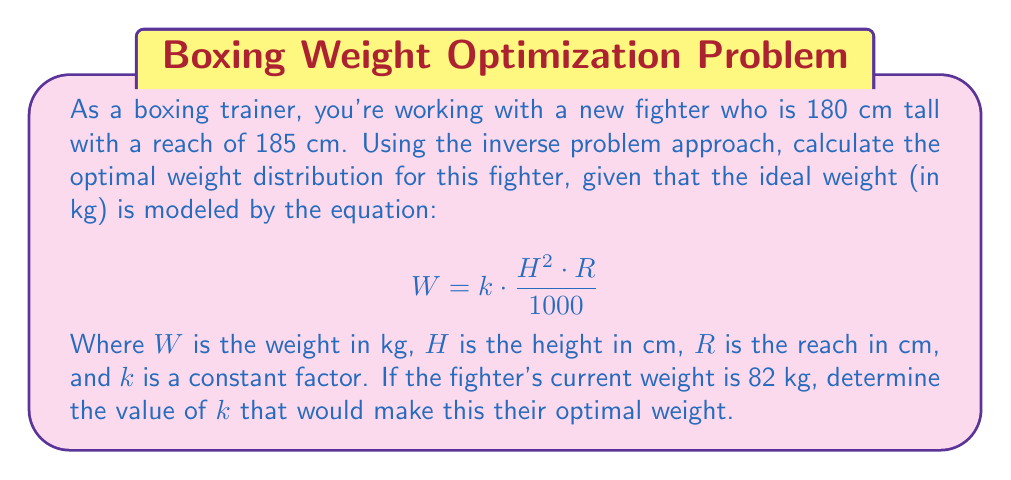Show me your answer to this math problem. To solve this inverse problem, we need to find the value of $k$ that satisfies the given equation with the known parameters. Let's approach this step-by-step:

1. We have the following information:
   - Height (H) = 180 cm
   - Reach (R) = 185 cm
   - Current weight (W) = 82 kg

2. The equation for ideal weight is:
   $$W = k \cdot \frac{H^2 \cdot R}{1000}$$

3. Substitute the known values into the equation:
   $$82 = k \cdot \frac{180^2 \cdot 185}{1000}$$

4. Simplify the right side of the equation:
   $$82 = k \cdot \frac{5,994,000}{1000} = k \cdot 5994$$

5. Solve for $k$:
   $$k = \frac{82}{5994} \approx 0.01368$$

6. Round to 4 decimal places for practicality:
   $$k \approx 0.0137$$

This value of $k$ would make the fighter's current weight of 82 kg their optimal weight according to the given model.
Answer: $k \approx 0.0137$ 